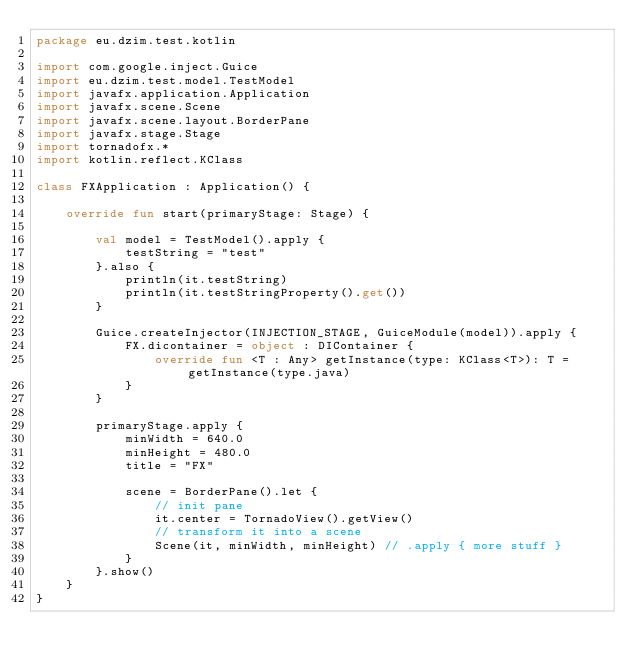<code> <loc_0><loc_0><loc_500><loc_500><_Kotlin_>package eu.dzim.test.kotlin

import com.google.inject.Guice
import eu.dzim.test.model.TestModel
import javafx.application.Application
import javafx.scene.Scene
import javafx.scene.layout.BorderPane
import javafx.stage.Stage
import tornadofx.*
import kotlin.reflect.KClass

class FXApplication : Application() {

    override fun start(primaryStage: Stage) {

        val model = TestModel().apply {
            testString = "test"
        }.also {
            println(it.testString)
            println(it.testStringProperty().get())
        }

        Guice.createInjector(INJECTION_STAGE, GuiceModule(model)).apply {
            FX.dicontainer = object : DIContainer {
                override fun <T : Any> getInstance(type: KClass<T>): T = getInstance(type.java)
            }
        }

        primaryStage.apply {
            minWidth = 640.0
            minHeight = 480.0
            title = "FX"

            scene = BorderPane().let {
                // init pane
                it.center = TornadoView().getView()
                // transform it into a scene
                Scene(it, minWidth, minHeight) // .apply { more stuff }
            }
        }.show()
    }
}</code> 